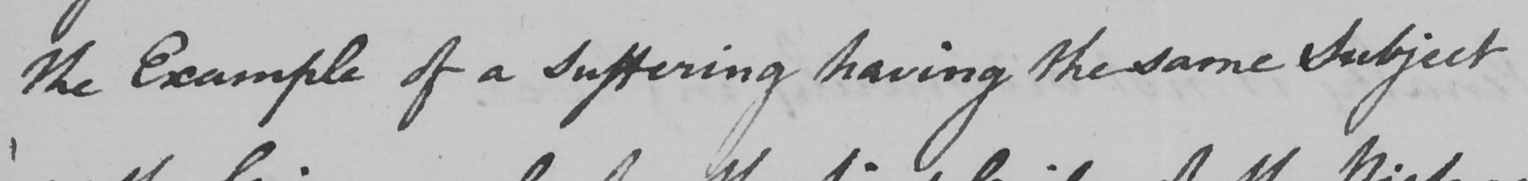Transcribe the text shown in this historical manuscript line. the Example of a suffering having the same Subject 